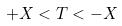Convert formula to latex. <formula><loc_0><loc_0><loc_500><loc_500>+ X < T < - X</formula> 